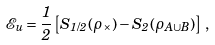Convert formula to latex. <formula><loc_0><loc_0><loc_500><loc_500>\mathcal { E } _ { u } = \frac { 1 } { 2 } \left [ S _ { 1 / 2 } ( \rho _ { \times } ) - S _ { 2 } ( \rho _ { A \cup B } ) \right ] \, ,</formula> 